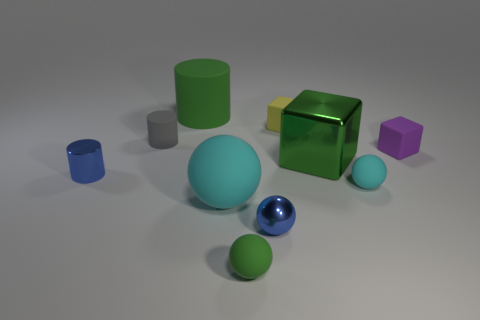Subtract 1 spheres. How many spheres are left? 3 Subtract all cylinders. How many objects are left? 7 Subtract all small green spheres. Subtract all purple blocks. How many objects are left? 8 Add 8 green shiny objects. How many green shiny objects are left? 9 Add 4 matte blocks. How many matte blocks exist? 6 Subtract 0 gray cubes. How many objects are left? 10 